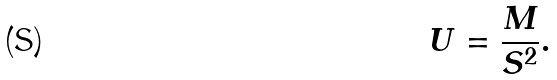Convert formula to latex. <formula><loc_0><loc_0><loc_500><loc_500>U = \frac { M } { S ^ { 2 } } .</formula> 